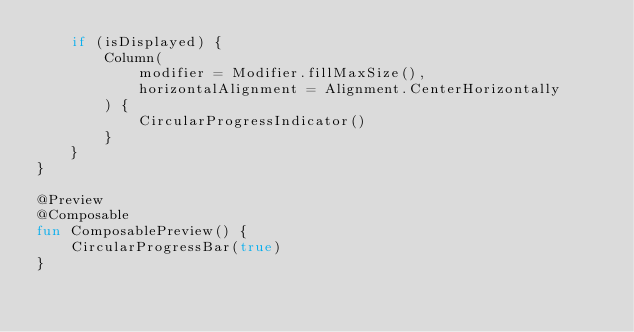<code> <loc_0><loc_0><loc_500><loc_500><_Kotlin_>    if (isDisplayed) {
        Column(
            modifier = Modifier.fillMaxSize(),
            horizontalAlignment = Alignment.CenterHorizontally
        ) {
            CircularProgressIndicator()
        }
    }
}

@Preview
@Composable
fun ComposablePreview() {
    CircularProgressBar(true)
}</code> 